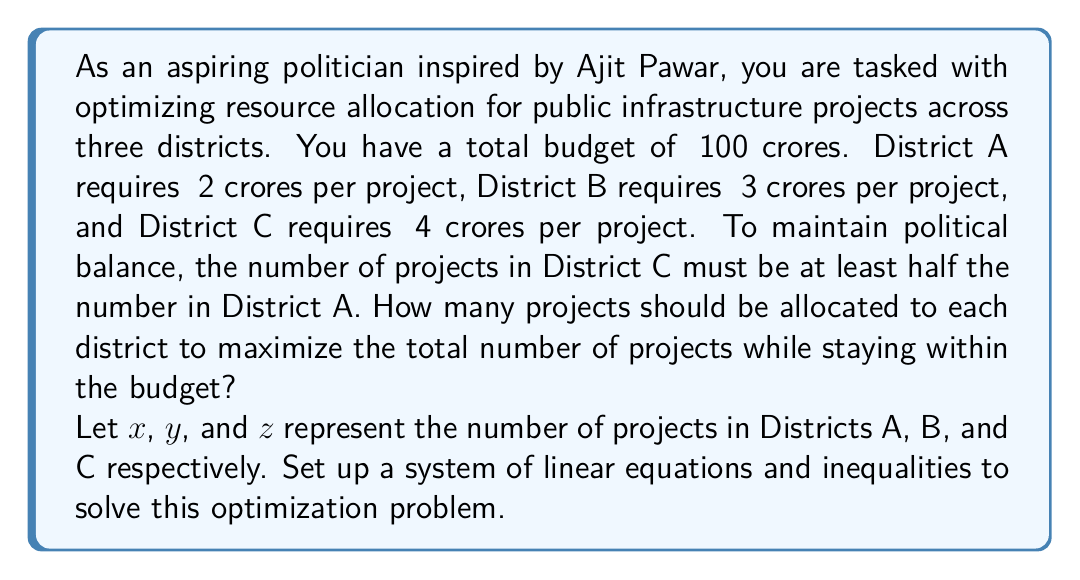Teach me how to tackle this problem. Let's approach this step-by-step:

1) First, we need to set up our constraints:

   a) Budget constraint: 
      $2x + 3y + 4z \leq 100$ (total cost ≤ total budget)

   b) Political balance constraint:
      $z \geq \frac{1}{2}x$ (projects in C ≥ half of projects in A)

   c) Non-negativity constraints:
      $x \geq 0$, $y \geq 0$, $z \geq 0$ (can't have negative projects)

2) Our objective is to maximize the total number of projects:
   Maximize $x + y + z$

3) This is a linear programming problem. We can solve it graphically or using the simplex method, but for this problem, we can use some logical reasoning:

   a) To maximize the number of projects, we should use the entire budget.
   b) District A projects are the cheapest, so we should allocate as many as possible to A, while satisfying the political constraint with C.

4) Let's express y in terms of x and z:
   $2x + 3y + 4z = 100$
   $y = \frac{100 - 2x - 4z}{3}$

5) Substitute this into our objective function:
   Maximize $x + \frac{100 - 2x - 4z}{3} + z$
            $= x + \frac{100}{3} - \frac{2x}{3} - \frac{4z}{3} + z$
            $= \frac{x}{3} + \frac{100}{3} - \frac{z}{3}$

6) This shows that to maximize the total, we should maximize x and minimize z, while keeping $z \geq \frac{1}{2}x$

7) Let's set $z = \frac{1}{2}x$ and solve:
   $2x + 3y + 4(\frac{1}{2}x) = 100$
   $2x + 3y + 2x = 100$
   $4x + 3y = 100$

8) To maximize x:
   $4x = 100$
   $x = 25$

9) Then:
   $z = \frac{1}{2}x = \frac{1}{2}(25) = 12.5$
   Round down to 12 to stay within budget.

10) Finally:
    $y = \frac{100 - 2(25) - 4(12)}{3} = \frac{100 - 50 - 48}{3} = \frac{2}{3}$
    Round down to 0 to stay within budget.

Therefore, the optimal allocation is 25 projects for District A, 0 for District B, and 12 for District C.
Answer: District A: 25, District B: 0, District C: 12 